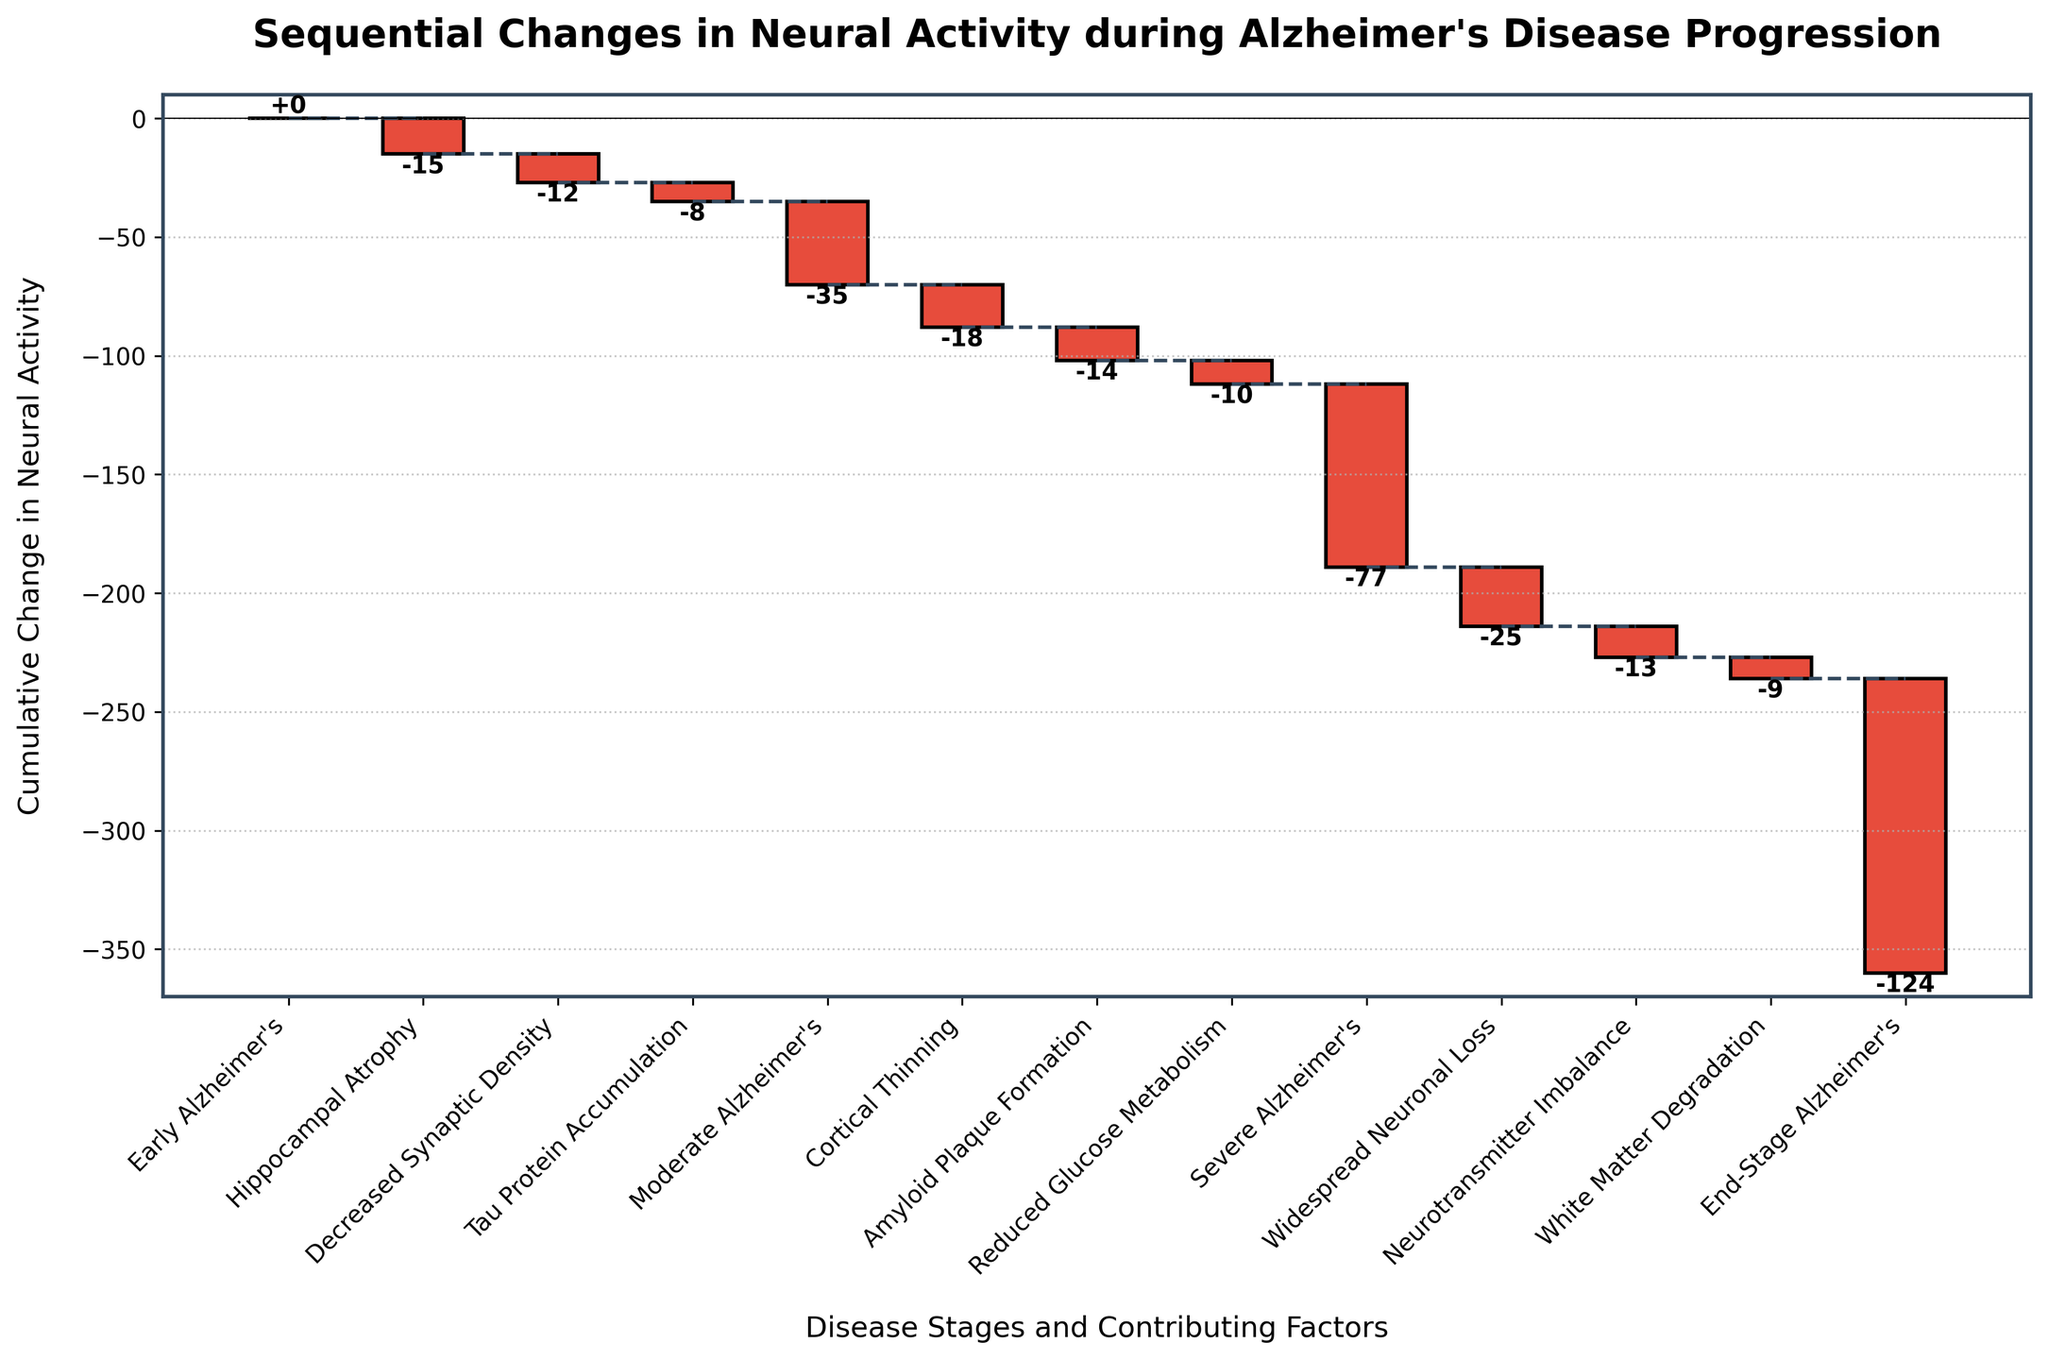What is the title of the chart? The title is written at the top of the chart. It provides a summary of what the chart is about.
Answer: Sequential Changes in Neural Activity during Alzheimer's Disease Progression Which stage has the greatest negative change in neural activity? By examining the height and labels of the red bars, the largest negative change is where the bar is the tallest and most negative.
Answer: Severe Alzheimer's What is the cumulative change in neural activity during the early stages of Alzheimer's, right before entering moderate Alzheimer's? Sum the changes from the initial stage through to Tau Protein Accumulation. 0 - 15 - 12 - 8 = -35
Answer: -35 Compare the cumulative neural activity change at the stage of moderate Alzheimer's and severe Alzheimer's. Which is more negative? By checking the vertical position of the stages on the y-axis, Severe Alzheimer's has a more negative cumulative change than Moderate Alzheimer's.
Answer: Severe Alzheimer's Referencing the changes at Cortical Thinning and White Matter Degradation, which one shows less negative impact on neural activity? Comparing the bar heights and changes, Cortical Thinning has -18, and White Matter Degradation has -9.
Answer: White Matter Degradation What is the neural activity change attributed to neuroinflammation in mid-to-late stages? This must be derived by logical deduction since neuroinflammation is not explicitly listed. It likely associates with factors such as Reduced Glucose Metabolism (-10).
Answer: -10 Which factor is responsible for the change immediately preceding the transition to Severe Alzheimer's? The chart shows Reduced Glucose Metabolism occurs right before Severe Alzheimer's.
Answer: Reduced Glucose Metabolism Determine the cumulative neural activity change from Moderate Alzheimer's to Severe Alzheimer's. Subtract the cumulative at Moderate Alzheimer's from Severe Alzheimer's: -77 - (-35) = -42
Answer: -42 What is the total neural activity change from the beginning to End-Stage Alzheimer's? Calculate the sum of all changes starting from Early Alzheimer's to End-Stage Alzheimer's cumulatively: 0-15-12-8-35-18-14-10-77-25-13-9 = -124
Answer: -124 